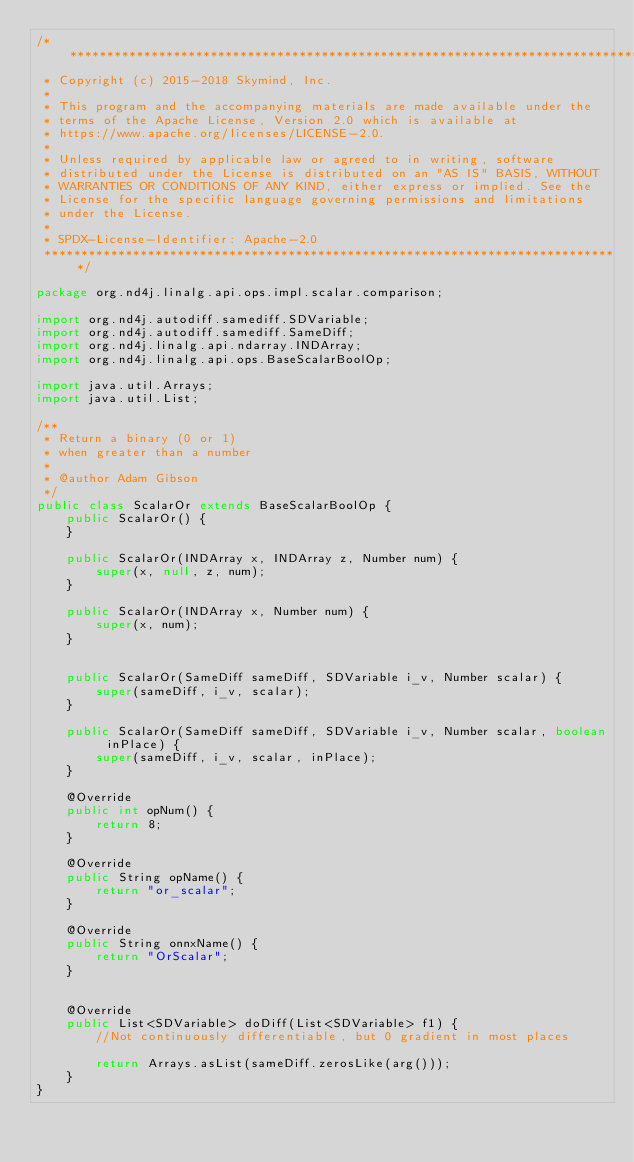Convert code to text. <code><loc_0><loc_0><loc_500><loc_500><_Java_>/*******************************************************************************
 * Copyright (c) 2015-2018 Skymind, Inc.
 *
 * This program and the accompanying materials are made available under the
 * terms of the Apache License, Version 2.0 which is available at
 * https://www.apache.org/licenses/LICENSE-2.0.
 *
 * Unless required by applicable law or agreed to in writing, software
 * distributed under the License is distributed on an "AS IS" BASIS, WITHOUT
 * WARRANTIES OR CONDITIONS OF ANY KIND, either express or implied. See the
 * License for the specific language governing permissions and limitations
 * under the License.
 *
 * SPDX-License-Identifier: Apache-2.0
 ******************************************************************************/

package org.nd4j.linalg.api.ops.impl.scalar.comparison;

import org.nd4j.autodiff.samediff.SDVariable;
import org.nd4j.autodiff.samediff.SameDiff;
import org.nd4j.linalg.api.ndarray.INDArray;
import org.nd4j.linalg.api.ops.BaseScalarBoolOp;

import java.util.Arrays;
import java.util.List;

/**
 * Return a binary (0 or 1)
 * when greater than a number
 *
 * @author Adam Gibson
 */
public class ScalarOr extends BaseScalarBoolOp {
    public ScalarOr() {
    }

    public ScalarOr(INDArray x, INDArray z, Number num) {
        super(x, null, z, num);
    }

    public ScalarOr(INDArray x, Number num) {
        super(x, num);
    }


    public ScalarOr(SameDiff sameDiff, SDVariable i_v, Number scalar) {
        super(sameDiff, i_v, scalar);
    }

    public ScalarOr(SameDiff sameDiff, SDVariable i_v, Number scalar, boolean inPlace) {
        super(sameDiff, i_v, scalar, inPlace);
    }

    @Override
    public int opNum() {
        return 8;
    }

    @Override
    public String opName() {
        return "or_scalar";
    }

    @Override
    public String onnxName() {
        return "OrScalar";
    }


    @Override
    public List<SDVariable> doDiff(List<SDVariable> f1) {
        //Not continuously differentiable, but 0 gradient in most places

        return Arrays.asList(sameDiff.zerosLike(arg()));
    }
}
</code> 